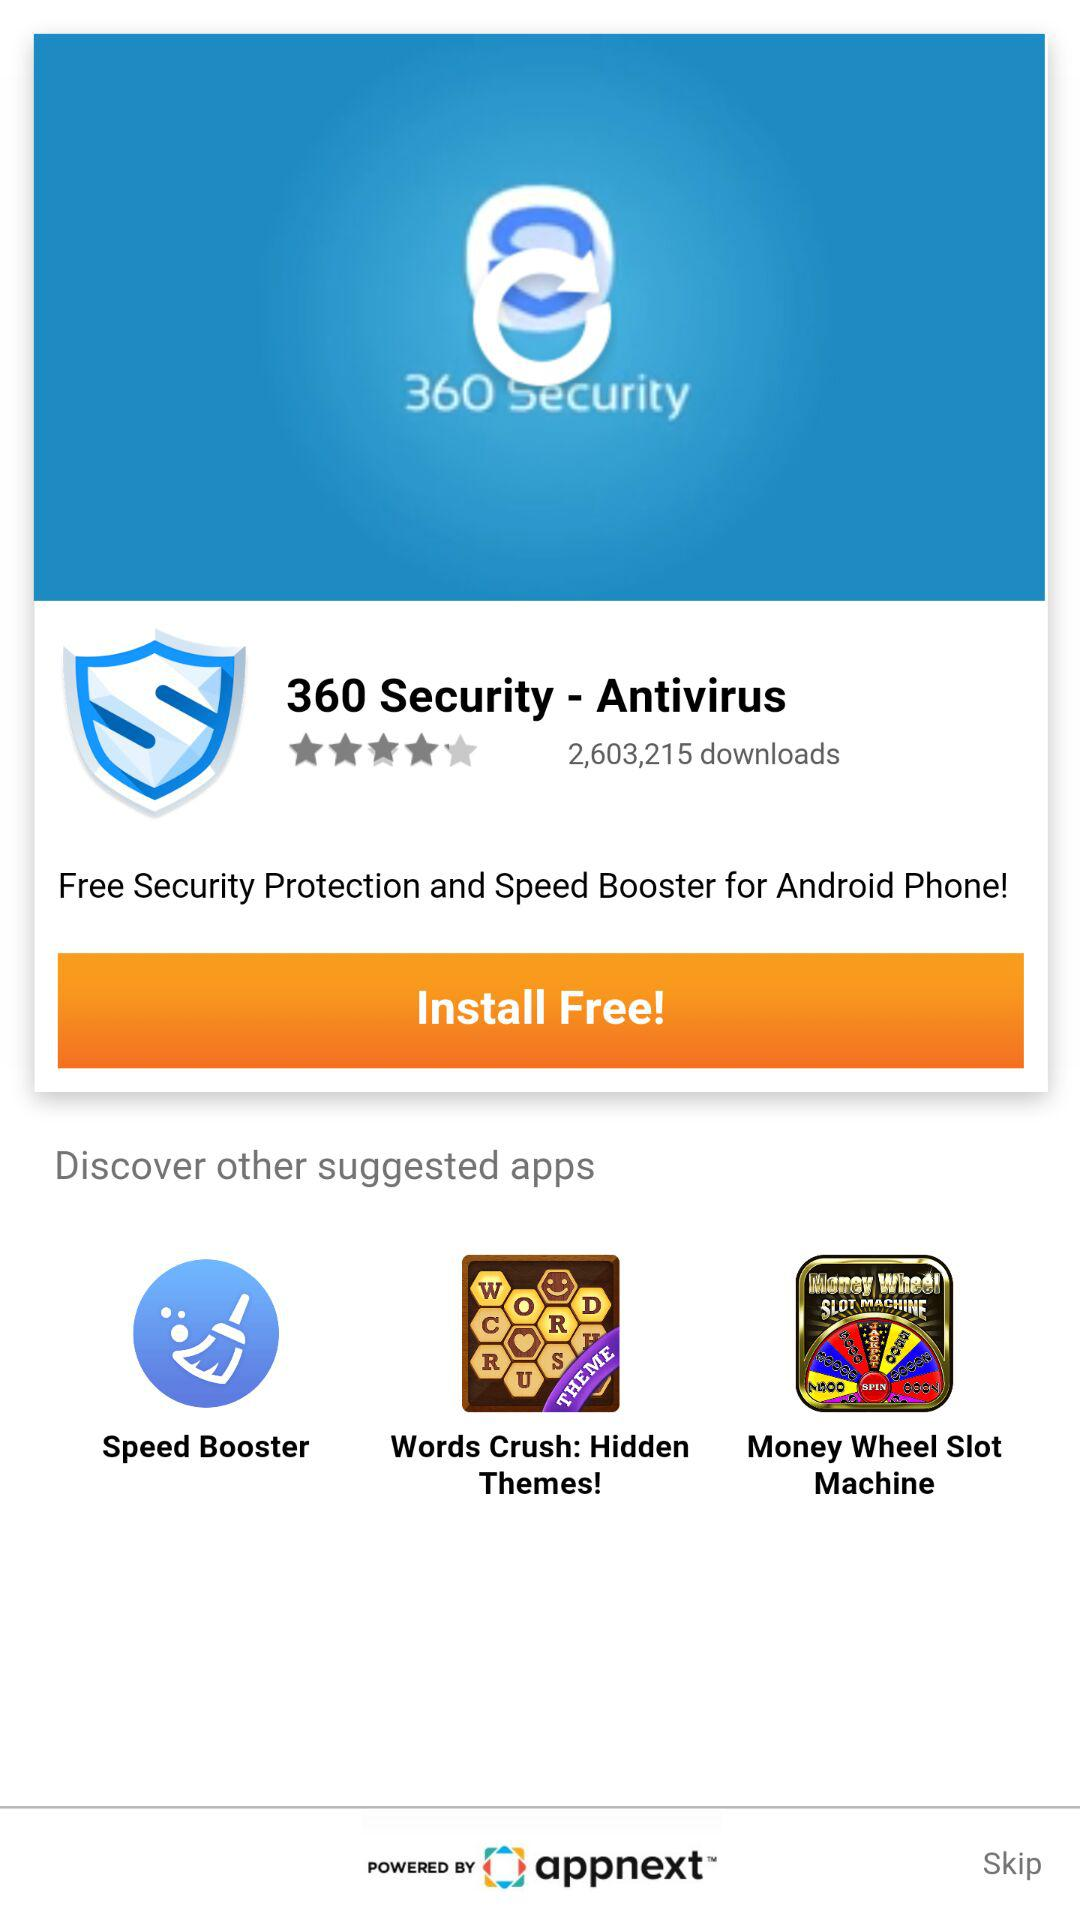What are the other suggested applications? The other suggested applications are "Speed Booster", "Words Crush: Hidden Themes!" and "Money Wheel Slot Machine". 